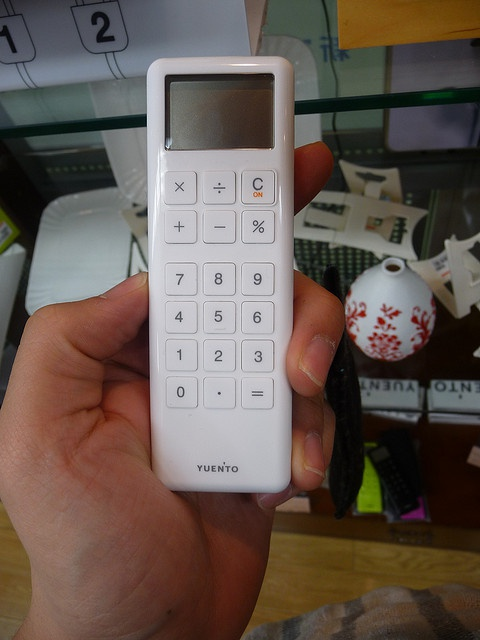Describe the objects in this image and their specific colors. I can see people in black, maroon, and brown tones, remote in black, lightgray, darkgray, and gray tones, and vase in black, darkgray, gray, and maroon tones in this image. 